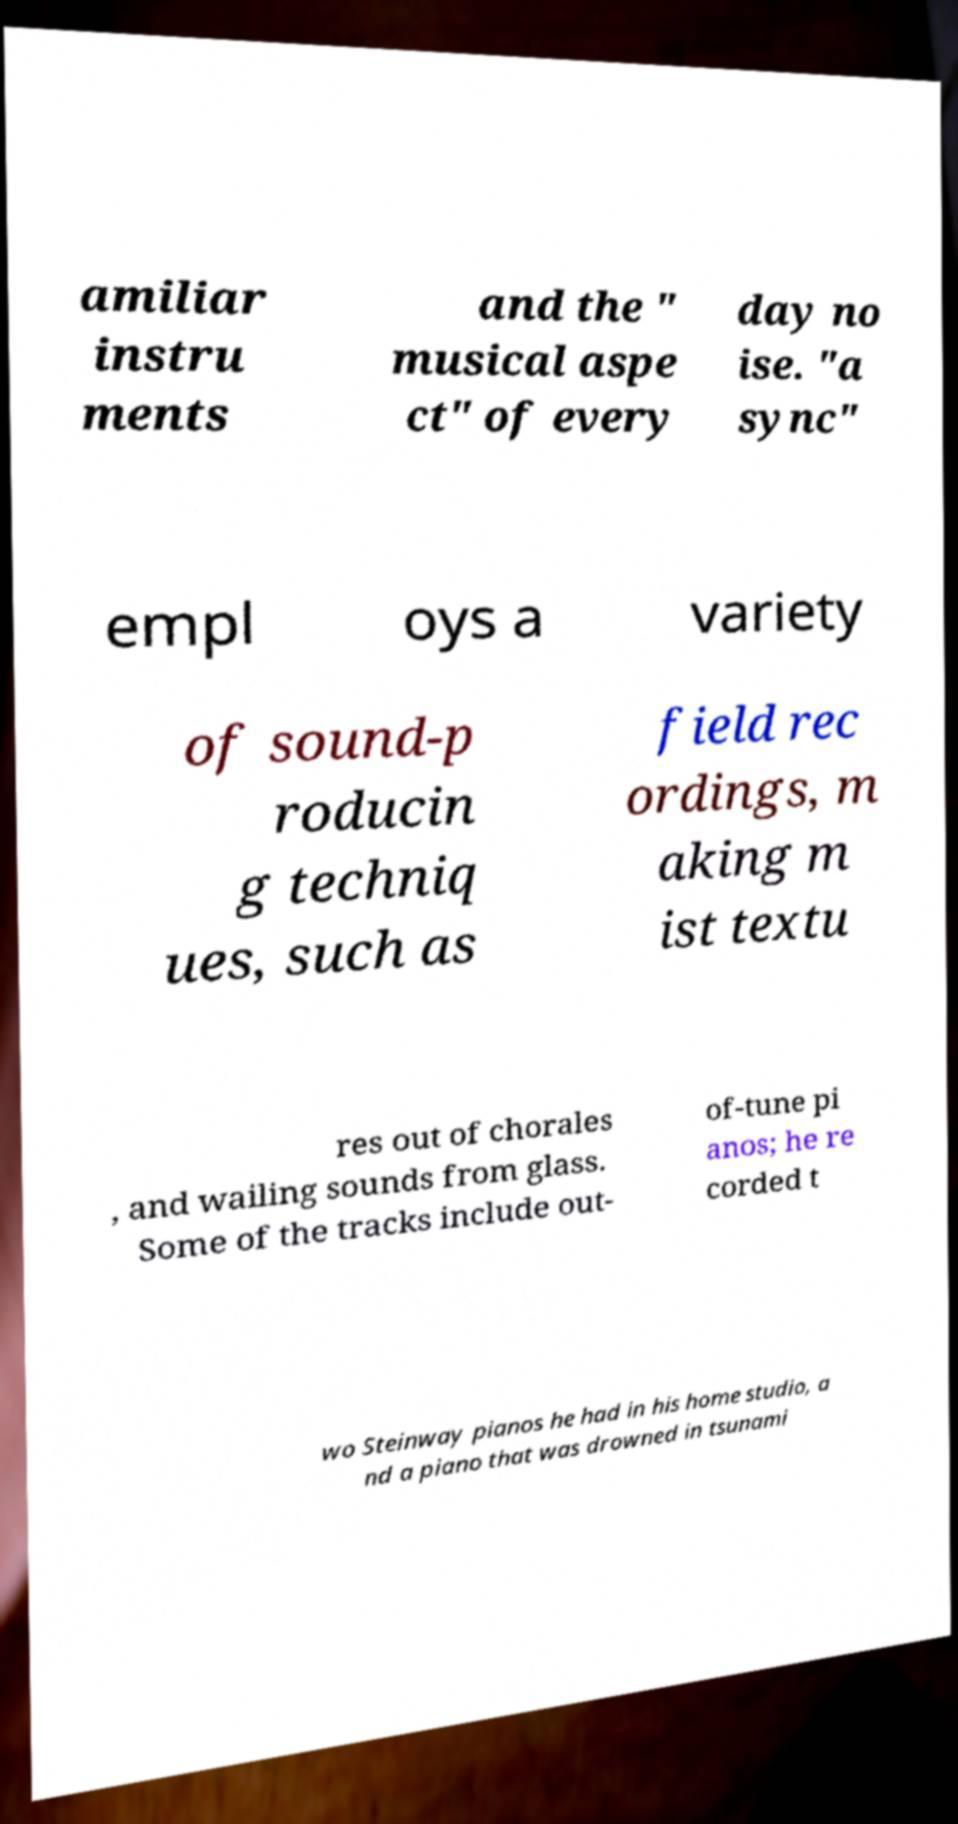Can you accurately transcribe the text from the provided image for me? amiliar instru ments and the " musical aspe ct" of every day no ise. "a sync" empl oys a variety of sound-p roducin g techniq ues, such as field rec ordings, m aking m ist textu res out of chorales , and wailing sounds from glass. Some of the tracks include out- of-tune pi anos; he re corded t wo Steinway pianos he had in his home studio, a nd a piano that was drowned in tsunami 